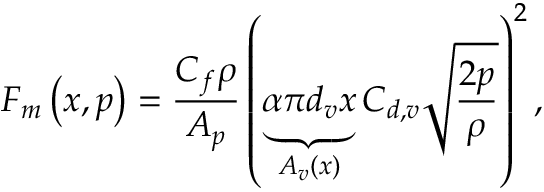Convert formula to latex. <formula><loc_0><loc_0><loc_500><loc_500>F _ { m } \left ( x , p \right ) = \frac { C _ { f } \rho } { A _ { p } } \left ( \underbrace { \alpha \pi d _ { v } x } _ { A _ { v } \left ( x \right ) } C _ { d , v } \sqrt { \frac { 2 p } { \rho } } \right ) ^ { 2 } ,</formula> 